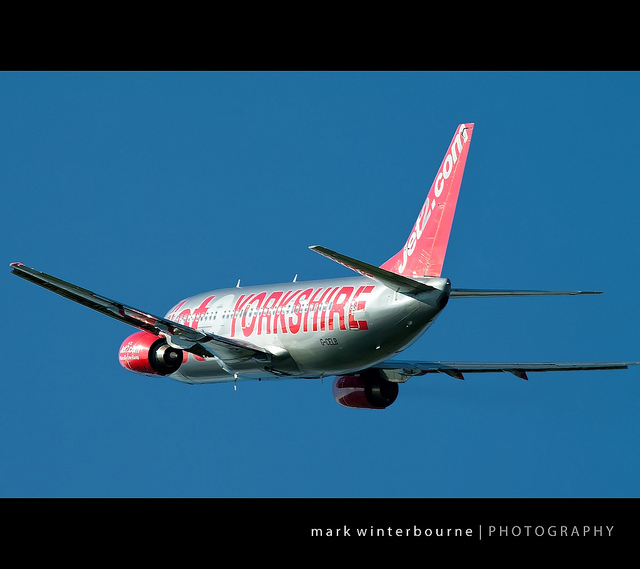Extract all visible text content from this image. mark winterbourne PHOTOGRAPHY jet2.com YORKSHIRE 